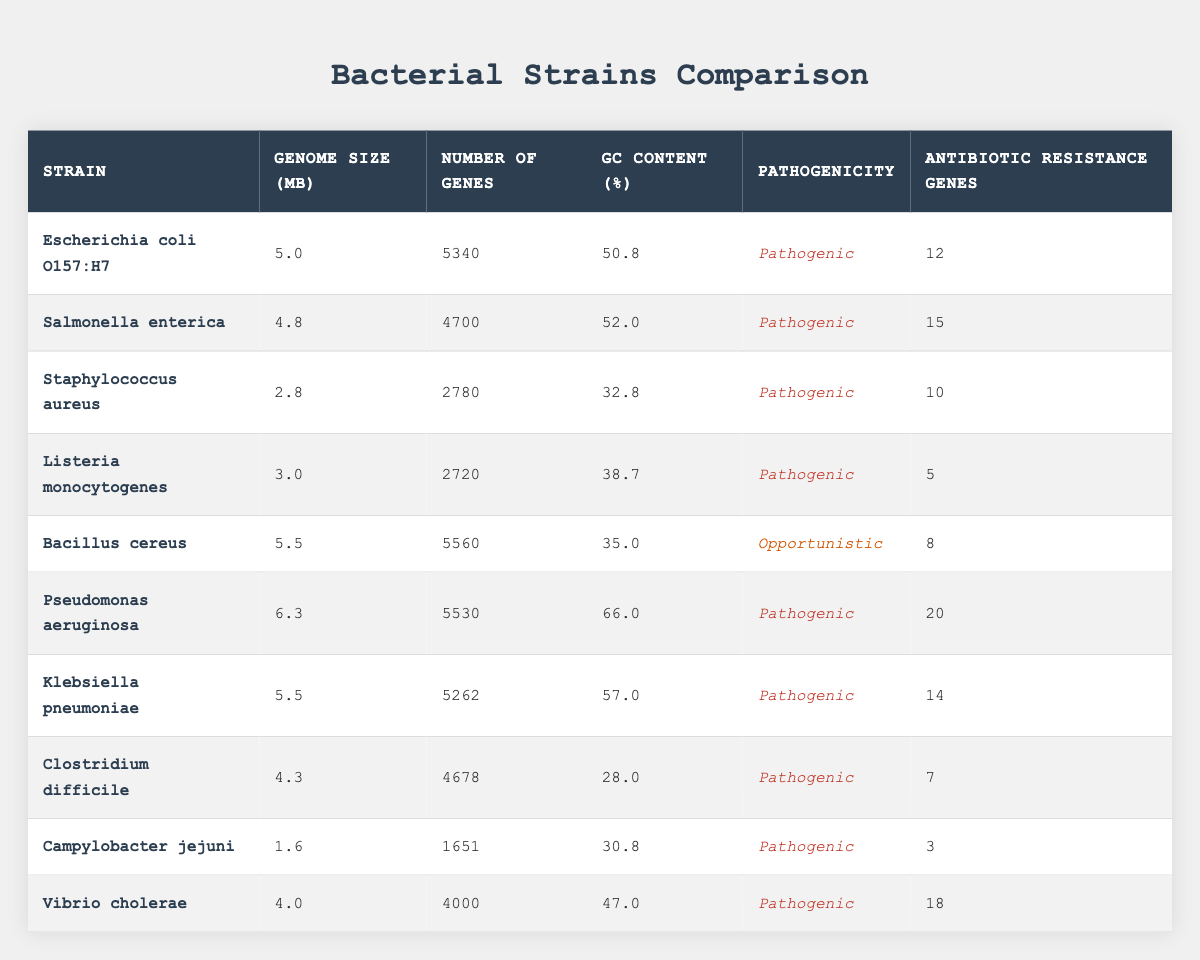What is the genome size of Pseudomonas aeruginosa? The table shows Pseudomonas aeruginosa's genome size listed in the "Genome Size (Mb)" column, which is 6.3 Mb.
Answer: 6.3 Mb How many antibiotic resistance genes does Salmonella enterica have? Referring to the table, Salmonella enterica has 15 antibiotic resistance genes listed in the "Antibiotic Resistance Genes" column.
Answer: 15 Which bacterial strain has the highest number of genes? By reviewing the "Number of Genes" column, I can see that Pseudomonas aeruginosa has 5530 genes, which is the highest among all listed strains.
Answer: Pseudomonas aeruginosa What is the average GC content of the listed bacterial strains? First, I find the total GC content: 50.8 + 52.0 + 32.8 + 38.7 + 35.0 + 66.0 + 57.0 + 28.0 + 30.8 + 47.0 =  408.1. Then, I divide by the number of strains (10): 408.1 / 10 = 40.81.
Answer: 40.81 Which strain has the lowest GC content, and what is its value? Looking at the "GC Content (%)" column, Clostridium difficile has the lowest GC content of 28.0%.
Answer: Clostridium difficile, 28.0% Is Escherichia coli O157:H7 considered pathogenic? The table shows that Escherichia coli O157:H7 is classified as "Pathogenic" in the "Pathogenicity" column.
Answer: Yes What is the difference in genome size between the largest and smallest strains? The largest strain is Pseudomonas aeruginosa with 6.3 Mb, and the smallest is Campylobacter jejuni with 1.6 Mb. The difference is 6.3 - 1.6 = 4.7 Mb.
Answer: 4.7 Mb How many strains have more than 5000 genes? I review the "Number of Genes" column and find that Escherichia coli O157:H7 (5340), Bacillus cereus (5560), and Pseudomonas aeruginosa (5530) have more than 5000 genes. Counting these, there are 3 strains.
Answer: 3 What percentage of strains listed are classified as pathogenic? There are a total of 10 strains, and 9 of them are classified as pathogenic. The percentage is (9/10) * 100 = 90%.
Answer: 90% Which strain has the most antibiotic resistance genes, and how many does it have? Checking the "Antibiotic Resistance Genes" column, Pseudomonas aeruginosa has the highest count at 20 genes.
Answer: Pseudomonas aeruginosa, 20 genes What is the median genome size of all bacterial strains? To find the median, I arrange the genome sizes in increasing order: 1.6, 2.8, 3.0, 4.0, 4.3, 4.8, 5.0, 5.5, 5.5, 6.3. With 10 values, the median is the average of the 5th (4.3) and 6th (4.8) values: (4.3 + 4.8) / 2 = 4.55.
Answer: 4.55 